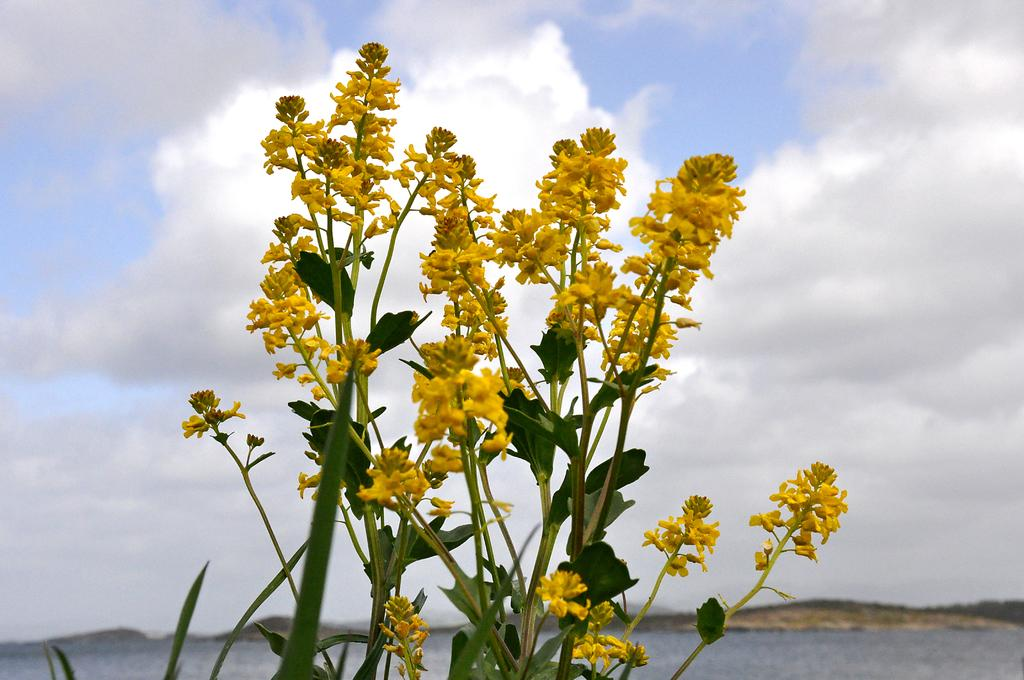What type of vegetation can be seen in the front of the image? There are flowers in the front of the image. What else can be seen in the image besides flowers? There are leaves in the image. What is visible in the background of the image? Water is visible in the background of the image. How would you describe the sky in the image? The sky is cloudy in the image. Can you hear the flowers laughing in the image? There is no sound or laughter in the image, as it is a still image of flowers, leaves, water, and a cloudy sky. 